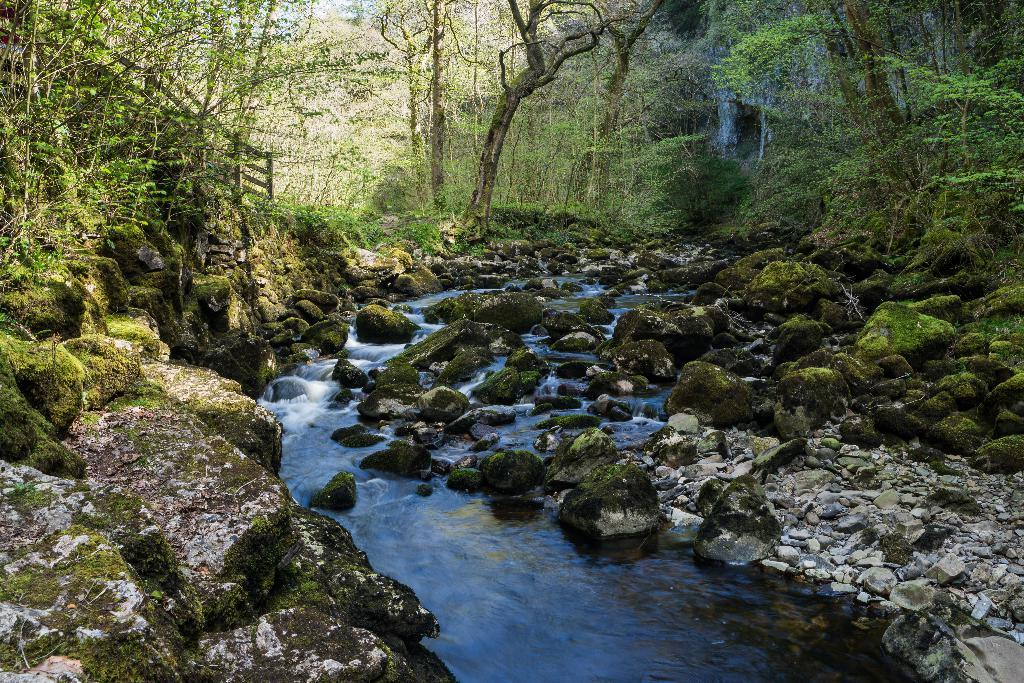What type of vegetation can be seen in the image? There are trees in the image. What is located at the center of the image? There is a water flow at the center of the image. What other natural elements are present in the image? There are rocks in the image. Can you see a worm crawling on the rocks in the image? There is no worm present in the image; it only features trees, a water flow, and rocks. What type of muscle can be seen in the image? There are no muscles present in the image, as it is a natural scene with trees, a water flow, and rocks. 